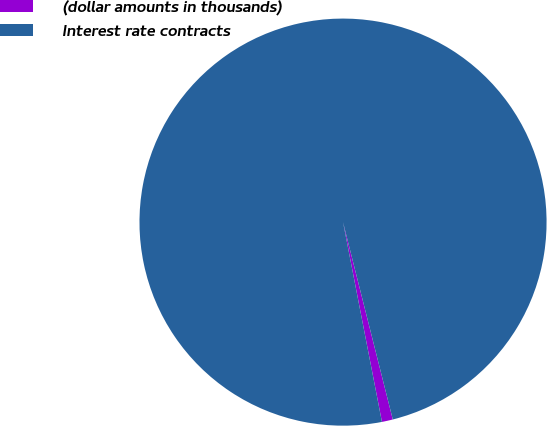Convert chart to OTSL. <chart><loc_0><loc_0><loc_500><loc_500><pie_chart><fcel>(dollar amounts in thousands)<fcel>Interest rate contracts<nl><fcel>0.87%<fcel>99.13%<nl></chart> 